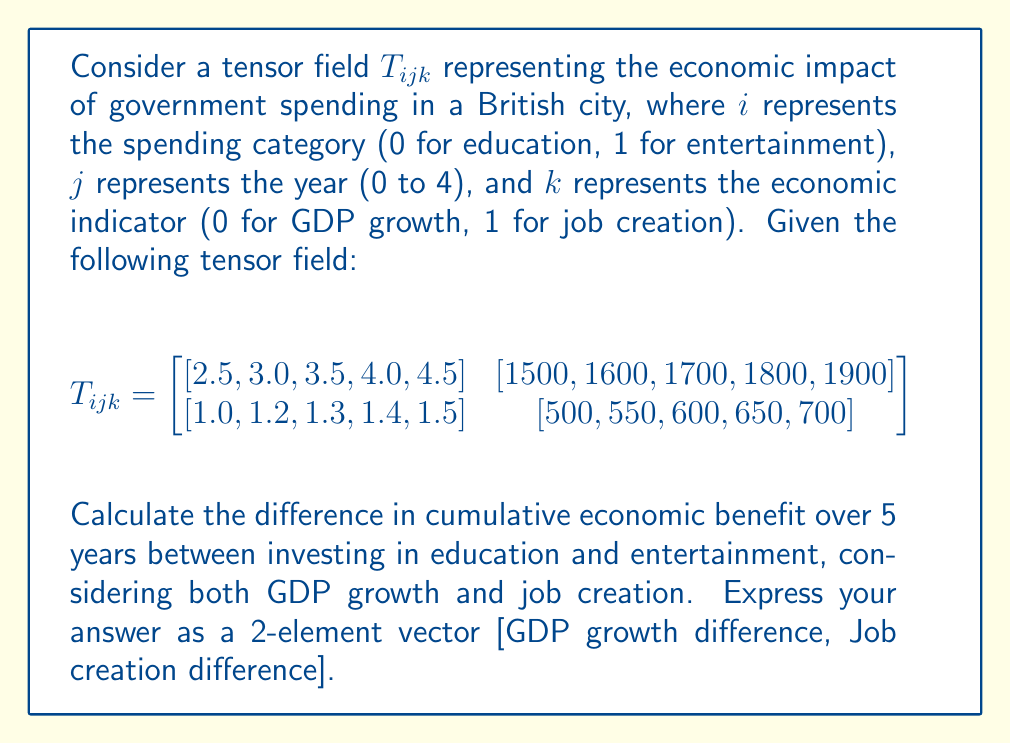Give your solution to this math problem. To solve this problem, we need to follow these steps:

1) First, let's understand the structure of the tensor field:
   - $T_{0jk}$ represents education
   - $T_{1jk}$ represents entertainment
   - $j$ from 0 to 4 represents years 1 to 5
   - $k=0$ is GDP growth, $k=1$ is job creation

2) Calculate the cumulative benefit for education:
   - GDP growth: $\sum_{j=0}^4 T_{0j0} = 2.5 + 3.0 + 3.5 + 4.0 + 4.5 = 17.5$
   - Job creation: $\sum_{j=0}^4 T_{0j1} = 1500 + 1600 + 1700 + 1800 + 1900 = 8500$

3) Calculate the cumulative benefit for entertainment:
   - GDP growth: $\sum_{j=0}^4 T_{1j0} = 1.0 + 1.2 + 1.3 + 1.4 + 1.5 = 6.4$
   - Job creation: $\sum_{j=0}^4 T_{1j1} = 500 + 550 + 600 + 650 + 700 = 3000$

4) Calculate the difference (education - entertainment):
   - GDP growth difference: $17.5 - 6.4 = 11.1$
   - Job creation difference: $8500 - 3000 = 5500$

5) Express the result as a 2-element vector:
   $[11.1, 5500]$

This result shows that over 5 years, investing in education provides 11.1 percentage points more GDP growth and creates 5500 more jobs compared to investing in entertainment.
Answer: $[11.1, 5500]$ 